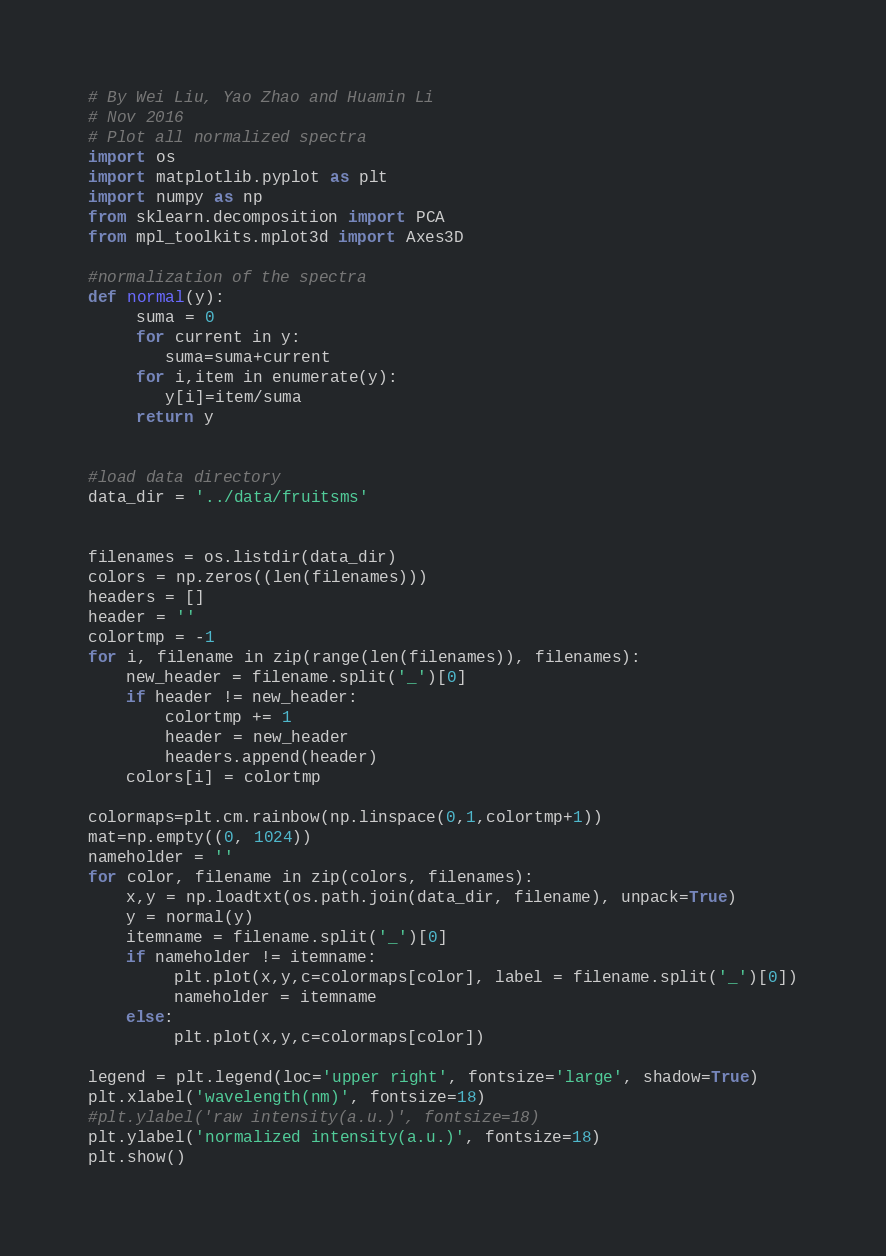<code> <loc_0><loc_0><loc_500><loc_500><_Python_># By Wei Liu, Yao Zhao and Huamin Li
# Nov 2016
# Plot all normalized spectra
import os
import matplotlib.pyplot as plt
import numpy as np
from sklearn.decomposition import PCA
from mpl_toolkits.mplot3d import Axes3D

#normalization of the spectra
def normal(y):
     suma = 0
     for current in y:
        suma=suma+current
     for i,item in enumerate(y):
        y[i]=item/suma
     return y


#load data directory
data_dir = '../data/fruitsms'


filenames = os.listdir(data_dir)
colors = np.zeros((len(filenames)))
headers = []
header = ''
colortmp = -1
for i, filename in zip(range(len(filenames)), filenames):
    new_header = filename.split('_')[0]
    if header != new_header:
        colortmp += 1
        header = new_header
        headers.append(header)
    colors[i] = colortmp

colormaps=plt.cm.rainbow(np.linspace(0,1,colortmp+1))
mat=np.empty((0, 1024))
nameholder = ''
for color, filename in zip(colors, filenames):
    x,y = np.loadtxt(os.path.join(data_dir, filename), unpack=True)
    y = normal(y)    
    itemname = filename.split('_')[0]
    if nameholder != itemname:     
         plt.plot(x,y,c=colormaps[color], label = filename.split('_')[0])
         nameholder = itemname
    else:
         plt.plot(x,y,c=colormaps[color])

legend = plt.legend(loc='upper right', fontsize='large', shadow=True)
plt.xlabel('wavelength(nm)', fontsize=18)
#plt.ylabel('raw intensity(a.u.)', fontsize=18)
plt.ylabel('normalized intensity(a.u.)', fontsize=18)
plt.show()


</code> 